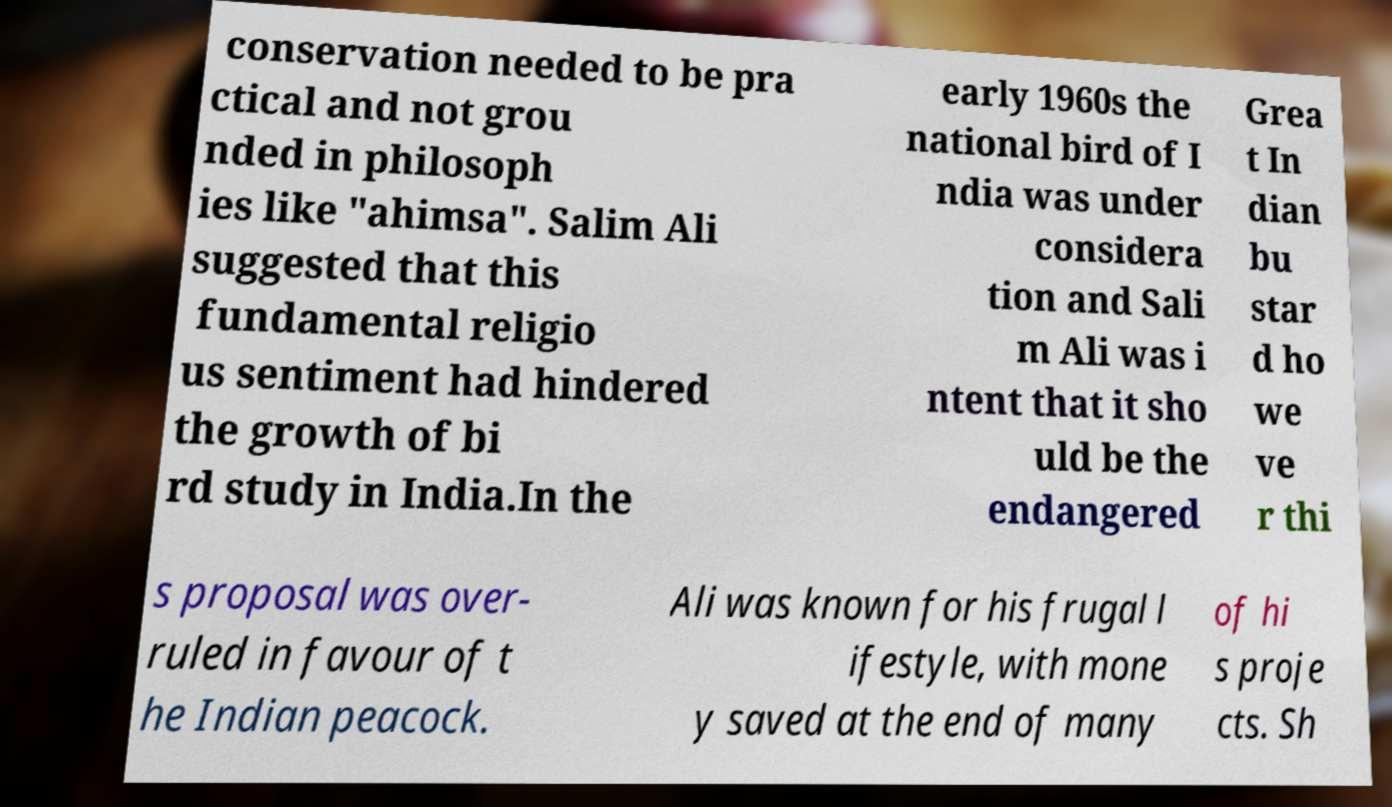For documentation purposes, I need the text within this image transcribed. Could you provide that? conservation needed to be pra ctical and not grou nded in philosoph ies like "ahimsa". Salim Ali suggested that this fundamental religio us sentiment had hindered the growth of bi rd study in India.In the early 1960s the national bird of I ndia was under considera tion and Sali m Ali was i ntent that it sho uld be the endangered Grea t In dian bu star d ho we ve r thi s proposal was over- ruled in favour of t he Indian peacock. Ali was known for his frugal l ifestyle, with mone y saved at the end of many of hi s proje cts. Sh 